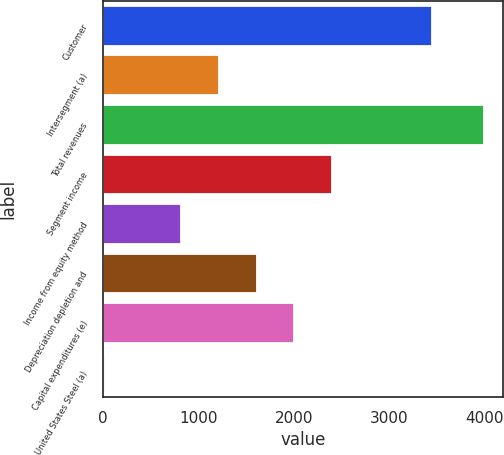Convert chart. <chart><loc_0><loc_0><loc_500><loc_500><bar_chart><fcel>Customer<fcel>Intersegment (a)<fcel>Total revenues<fcel>Segment income<fcel>Income from equity method<fcel>Depreciation depletion and<fcel>Capital expenditures (e)<fcel>United States Steel (a)<nl><fcel>3445<fcel>1211.7<fcel>3990<fcel>2402.4<fcel>814.8<fcel>1608.6<fcel>2005.5<fcel>21<nl></chart> 